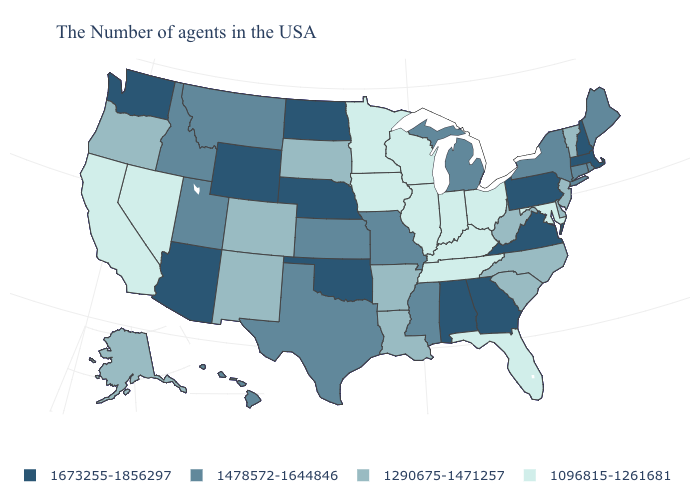What is the highest value in the West ?
Write a very short answer. 1673255-1856297. Does the map have missing data?
Write a very short answer. No. Among the states that border Utah , does Idaho have the highest value?
Write a very short answer. No. What is the value of Maryland?
Concise answer only. 1096815-1261681. Name the states that have a value in the range 1478572-1644846?
Write a very short answer. Maine, Rhode Island, Connecticut, New York, Michigan, Mississippi, Missouri, Kansas, Texas, Utah, Montana, Idaho, Hawaii. Name the states that have a value in the range 1673255-1856297?
Be succinct. Massachusetts, New Hampshire, Pennsylvania, Virginia, Georgia, Alabama, Nebraska, Oklahoma, North Dakota, Wyoming, Arizona, Washington. Name the states that have a value in the range 1673255-1856297?
Quick response, please. Massachusetts, New Hampshire, Pennsylvania, Virginia, Georgia, Alabama, Nebraska, Oklahoma, North Dakota, Wyoming, Arizona, Washington. Among the states that border South Carolina , which have the highest value?
Answer briefly. Georgia. Name the states that have a value in the range 1673255-1856297?
Keep it brief. Massachusetts, New Hampshire, Pennsylvania, Virginia, Georgia, Alabama, Nebraska, Oklahoma, North Dakota, Wyoming, Arizona, Washington. What is the lowest value in states that border Rhode Island?
Keep it brief. 1478572-1644846. Which states hav the highest value in the South?
Answer briefly. Virginia, Georgia, Alabama, Oklahoma. What is the lowest value in the USA?
Give a very brief answer. 1096815-1261681. Does Louisiana have a higher value than Hawaii?
Quick response, please. No. What is the lowest value in states that border West Virginia?
Write a very short answer. 1096815-1261681. How many symbols are there in the legend?
Quick response, please. 4. 